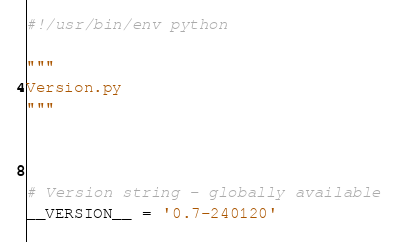<code> <loc_0><loc_0><loc_500><loc_500><_Python_>#!/usr/bin/env python

"""
Version.py
"""



# Version string - globally available
__VERSION__ = '0.7-240120'
</code> 